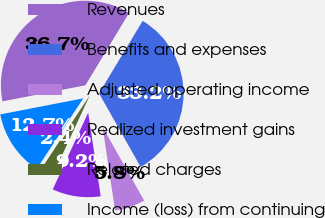<chart> <loc_0><loc_0><loc_500><loc_500><pie_chart><fcel>Revenues<fcel>Benefits and expenses<fcel>Adjusted operating income<fcel>Realized investment gains<fcel>Related charges<fcel>Income (loss) from continuing<nl><fcel>36.68%<fcel>33.18%<fcel>5.82%<fcel>9.25%<fcel>2.39%<fcel>12.68%<nl></chart> 